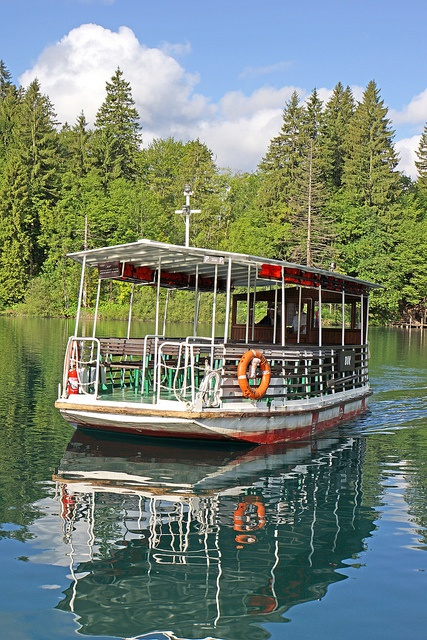Describe the objects in this image and their specific colors. I can see boat in lightblue, black, gray, olive, and white tones, people in lightblue, black, gray, and darkgreen tones, people in lightblue, black, khaki, and olive tones, and people in lightblue, black, maroon, purple, and gray tones in this image. 